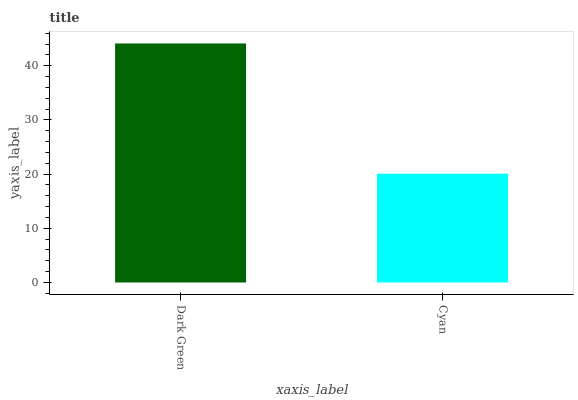Is Cyan the minimum?
Answer yes or no. Yes. Is Dark Green the maximum?
Answer yes or no. Yes. Is Cyan the maximum?
Answer yes or no. No. Is Dark Green greater than Cyan?
Answer yes or no. Yes. Is Cyan less than Dark Green?
Answer yes or no. Yes. Is Cyan greater than Dark Green?
Answer yes or no. No. Is Dark Green less than Cyan?
Answer yes or no. No. Is Dark Green the high median?
Answer yes or no. Yes. Is Cyan the low median?
Answer yes or no. Yes. Is Cyan the high median?
Answer yes or no. No. Is Dark Green the low median?
Answer yes or no. No. 